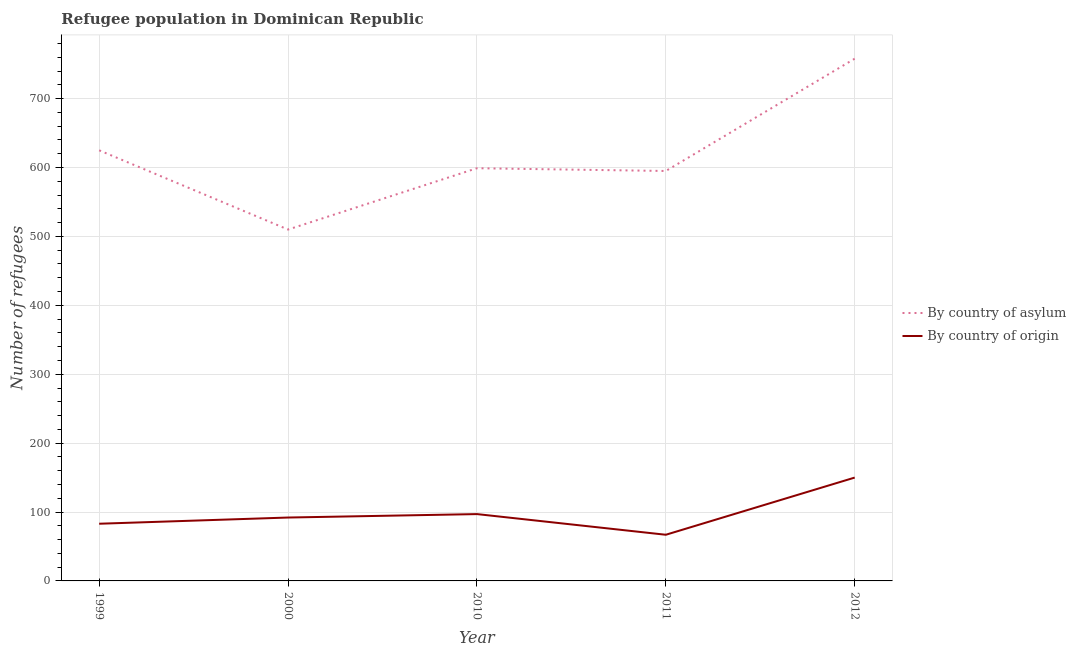How many different coloured lines are there?
Offer a very short reply. 2. What is the number of refugees by country of origin in 2000?
Provide a succinct answer. 92. Across all years, what is the maximum number of refugees by country of origin?
Make the answer very short. 150. Across all years, what is the minimum number of refugees by country of asylum?
Make the answer very short. 510. In which year was the number of refugees by country of origin minimum?
Give a very brief answer. 2011. What is the total number of refugees by country of origin in the graph?
Give a very brief answer. 489. What is the difference between the number of refugees by country of origin in 1999 and that in 2010?
Offer a terse response. -14. What is the difference between the number of refugees by country of origin in 2000 and the number of refugees by country of asylum in 1999?
Ensure brevity in your answer.  -533. What is the average number of refugees by country of origin per year?
Your response must be concise. 97.8. In the year 2011, what is the difference between the number of refugees by country of origin and number of refugees by country of asylum?
Provide a succinct answer. -528. What is the ratio of the number of refugees by country of origin in 1999 to that in 2011?
Give a very brief answer. 1.24. Is the difference between the number of refugees by country of asylum in 2000 and 2012 greater than the difference between the number of refugees by country of origin in 2000 and 2012?
Make the answer very short. No. What is the difference between the highest and the second highest number of refugees by country of asylum?
Your answer should be very brief. 133. What is the difference between the highest and the lowest number of refugees by country of asylum?
Ensure brevity in your answer.  248. Is the sum of the number of refugees by country of asylum in 2000 and 2011 greater than the maximum number of refugees by country of origin across all years?
Offer a very short reply. Yes. Is the number of refugees by country of asylum strictly greater than the number of refugees by country of origin over the years?
Provide a short and direct response. Yes. How many lines are there?
Your response must be concise. 2. What is the difference between two consecutive major ticks on the Y-axis?
Offer a terse response. 100. How many legend labels are there?
Give a very brief answer. 2. What is the title of the graph?
Provide a succinct answer. Refugee population in Dominican Republic. Does "constant 2005 US$" appear as one of the legend labels in the graph?
Offer a very short reply. No. What is the label or title of the X-axis?
Give a very brief answer. Year. What is the label or title of the Y-axis?
Make the answer very short. Number of refugees. What is the Number of refugees in By country of asylum in 1999?
Provide a short and direct response. 625. What is the Number of refugees of By country of asylum in 2000?
Provide a succinct answer. 510. What is the Number of refugees in By country of origin in 2000?
Provide a succinct answer. 92. What is the Number of refugees in By country of asylum in 2010?
Your answer should be compact. 599. What is the Number of refugees in By country of origin in 2010?
Keep it short and to the point. 97. What is the Number of refugees of By country of asylum in 2011?
Provide a succinct answer. 595. What is the Number of refugees in By country of origin in 2011?
Provide a short and direct response. 67. What is the Number of refugees in By country of asylum in 2012?
Provide a succinct answer. 758. What is the Number of refugees of By country of origin in 2012?
Provide a succinct answer. 150. Across all years, what is the maximum Number of refugees in By country of asylum?
Give a very brief answer. 758. Across all years, what is the maximum Number of refugees in By country of origin?
Your answer should be compact. 150. Across all years, what is the minimum Number of refugees in By country of asylum?
Provide a short and direct response. 510. Across all years, what is the minimum Number of refugees of By country of origin?
Offer a very short reply. 67. What is the total Number of refugees in By country of asylum in the graph?
Provide a succinct answer. 3087. What is the total Number of refugees in By country of origin in the graph?
Give a very brief answer. 489. What is the difference between the Number of refugees in By country of asylum in 1999 and that in 2000?
Offer a very short reply. 115. What is the difference between the Number of refugees of By country of asylum in 1999 and that in 2010?
Make the answer very short. 26. What is the difference between the Number of refugees of By country of asylum in 1999 and that in 2012?
Keep it short and to the point. -133. What is the difference between the Number of refugees in By country of origin in 1999 and that in 2012?
Keep it short and to the point. -67. What is the difference between the Number of refugees in By country of asylum in 2000 and that in 2010?
Your answer should be very brief. -89. What is the difference between the Number of refugees of By country of origin in 2000 and that in 2010?
Keep it short and to the point. -5. What is the difference between the Number of refugees in By country of asylum in 2000 and that in 2011?
Offer a very short reply. -85. What is the difference between the Number of refugees in By country of asylum in 2000 and that in 2012?
Offer a terse response. -248. What is the difference between the Number of refugees of By country of origin in 2000 and that in 2012?
Give a very brief answer. -58. What is the difference between the Number of refugees of By country of origin in 2010 and that in 2011?
Your response must be concise. 30. What is the difference between the Number of refugees of By country of asylum in 2010 and that in 2012?
Offer a very short reply. -159. What is the difference between the Number of refugees in By country of origin in 2010 and that in 2012?
Provide a short and direct response. -53. What is the difference between the Number of refugees in By country of asylum in 2011 and that in 2012?
Provide a succinct answer. -163. What is the difference between the Number of refugees in By country of origin in 2011 and that in 2012?
Provide a short and direct response. -83. What is the difference between the Number of refugees in By country of asylum in 1999 and the Number of refugees in By country of origin in 2000?
Provide a succinct answer. 533. What is the difference between the Number of refugees in By country of asylum in 1999 and the Number of refugees in By country of origin in 2010?
Your response must be concise. 528. What is the difference between the Number of refugees in By country of asylum in 1999 and the Number of refugees in By country of origin in 2011?
Keep it short and to the point. 558. What is the difference between the Number of refugees in By country of asylum in 1999 and the Number of refugees in By country of origin in 2012?
Make the answer very short. 475. What is the difference between the Number of refugees of By country of asylum in 2000 and the Number of refugees of By country of origin in 2010?
Offer a very short reply. 413. What is the difference between the Number of refugees in By country of asylum in 2000 and the Number of refugees in By country of origin in 2011?
Provide a short and direct response. 443. What is the difference between the Number of refugees in By country of asylum in 2000 and the Number of refugees in By country of origin in 2012?
Your response must be concise. 360. What is the difference between the Number of refugees in By country of asylum in 2010 and the Number of refugees in By country of origin in 2011?
Make the answer very short. 532. What is the difference between the Number of refugees in By country of asylum in 2010 and the Number of refugees in By country of origin in 2012?
Make the answer very short. 449. What is the difference between the Number of refugees in By country of asylum in 2011 and the Number of refugees in By country of origin in 2012?
Make the answer very short. 445. What is the average Number of refugees in By country of asylum per year?
Offer a terse response. 617.4. What is the average Number of refugees of By country of origin per year?
Make the answer very short. 97.8. In the year 1999, what is the difference between the Number of refugees of By country of asylum and Number of refugees of By country of origin?
Provide a succinct answer. 542. In the year 2000, what is the difference between the Number of refugees in By country of asylum and Number of refugees in By country of origin?
Ensure brevity in your answer.  418. In the year 2010, what is the difference between the Number of refugees of By country of asylum and Number of refugees of By country of origin?
Provide a short and direct response. 502. In the year 2011, what is the difference between the Number of refugees in By country of asylum and Number of refugees in By country of origin?
Your answer should be compact. 528. In the year 2012, what is the difference between the Number of refugees in By country of asylum and Number of refugees in By country of origin?
Provide a short and direct response. 608. What is the ratio of the Number of refugees of By country of asylum in 1999 to that in 2000?
Provide a short and direct response. 1.23. What is the ratio of the Number of refugees of By country of origin in 1999 to that in 2000?
Provide a succinct answer. 0.9. What is the ratio of the Number of refugees of By country of asylum in 1999 to that in 2010?
Your answer should be very brief. 1.04. What is the ratio of the Number of refugees in By country of origin in 1999 to that in 2010?
Provide a short and direct response. 0.86. What is the ratio of the Number of refugees in By country of asylum in 1999 to that in 2011?
Offer a very short reply. 1.05. What is the ratio of the Number of refugees of By country of origin in 1999 to that in 2011?
Keep it short and to the point. 1.24. What is the ratio of the Number of refugees of By country of asylum in 1999 to that in 2012?
Keep it short and to the point. 0.82. What is the ratio of the Number of refugees in By country of origin in 1999 to that in 2012?
Give a very brief answer. 0.55. What is the ratio of the Number of refugees in By country of asylum in 2000 to that in 2010?
Your answer should be compact. 0.85. What is the ratio of the Number of refugees of By country of origin in 2000 to that in 2010?
Keep it short and to the point. 0.95. What is the ratio of the Number of refugees in By country of origin in 2000 to that in 2011?
Provide a succinct answer. 1.37. What is the ratio of the Number of refugees in By country of asylum in 2000 to that in 2012?
Your response must be concise. 0.67. What is the ratio of the Number of refugees of By country of origin in 2000 to that in 2012?
Offer a terse response. 0.61. What is the ratio of the Number of refugees of By country of asylum in 2010 to that in 2011?
Give a very brief answer. 1.01. What is the ratio of the Number of refugees in By country of origin in 2010 to that in 2011?
Offer a terse response. 1.45. What is the ratio of the Number of refugees of By country of asylum in 2010 to that in 2012?
Make the answer very short. 0.79. What is the ratio of the Number of refugees of By country of origin in 2010 to that in 2012?
Your answer should be compact. 0.65. What is the ratio of the Number of refugees of By country of asylum in 2011 to that in 2012?
Keep it short and to the point. 0.79. What is the ratio of the Number of refugees of By country of origin in 2011 to that in 2012?
Give a very brief answer. 0.45. What is the difference between the highest and the second highest Number of refugees in By country of asylum?
Your answer should be very brief. 133. What is the difference between the highest and the second highest Number of refugees of By country of origin?
Your answer should be very brief. 53. What is the difference between the highest and the lowest Number of refugees in By country of asylum?
Ensure brevity in your answer.  248. What is the difference between the highest and the lowest Number of refugees in By country of origin?
Your response must be concise. 83. 